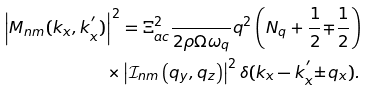Convert formula to latex. <formula><loc_0><loc_0><loc_500><loc_500>\left | M _ { n m } ( k _ { x } , k _ { x } ^ { ^ { \prime } } ) \right | ^ { 2 } & = \Xi _ { a c } ^ { 2 } \frac { } { 2 \rho \Omega \omega _ { q } } q ^ { 2 } \left ( N _ { q } + \frac { 1 } { 2 } { \mp } \frac { 1 } { 2 } \right ) \\ \times & \left | \mathcal { I } _ { n m } \left ( q _ { y } , q _ { z } \right ) \right | ^ { 2 } \delta ( k _ { x } - k _ { x } ^ { ^ { \prime } } { \pm } q _ { x } ) .</formula> 